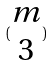<formula> <loc_0><loc_0><loc_500><loc_500>( \begin{matrix} m \\ 3 \end{matrix} )</formula> 